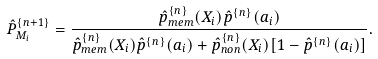<formula> <loc_0><loc_0><loc_500><loc_500>\hat { P } _ { M _ { i } } ^ { \{ n + 1 \} } = \frac { \hat { p } _ { m e m } ^ { \{ n \} } ( X _ { i } ) \hat { p } ^ { \{ n \} } ( a _ { i } ) } { \hat { p } ^ { \{ n \} } _ { m e m } ( X _ { i } ) \hat { p } ^ { \{ n \} } ( a _ { i } ) + \hat { p } ^ { \{ n \} } _ { n o n } ( X _ { i } ) [ 1 - \hat { p } ^ { \{ n \} } ( a _ { i } ) ] } .</formula> 